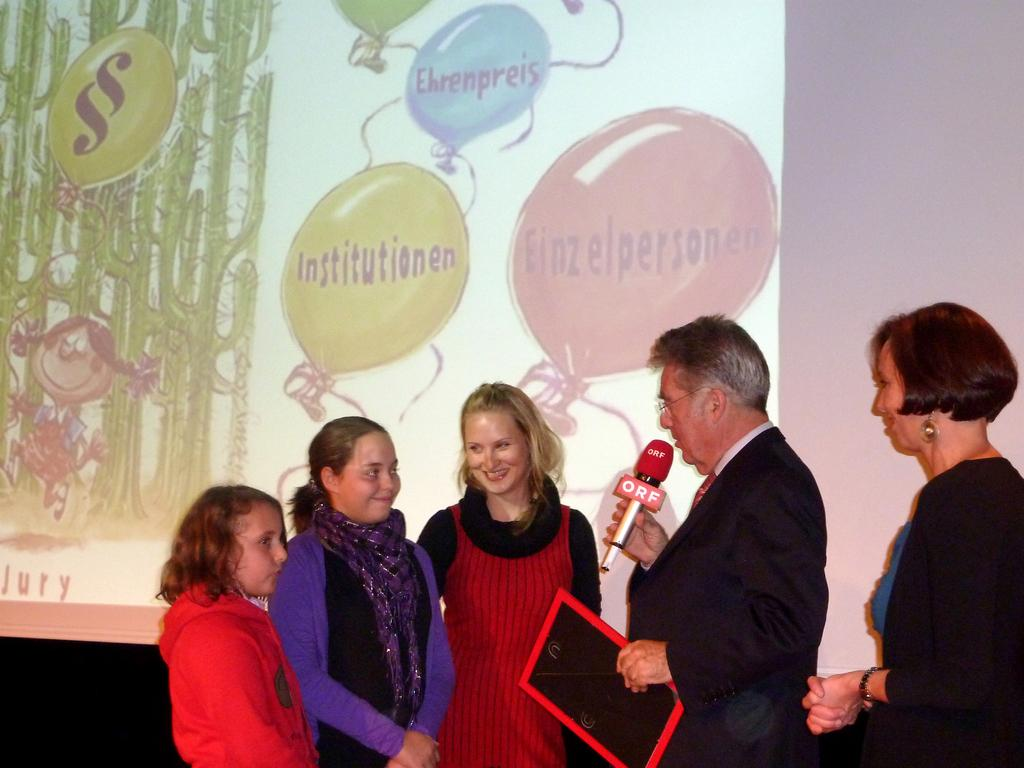What can be seen in the image? There are people standing in the image. Where are the people standing? The people are standing on the floor. What else is visible in the image besides the people? There is a banner visible in the image. What type of coal is being used to rake the floor in the image? There is no coal or rake present in the image. How many bikes can be seen in the image? There are no bikes visible in the image. 